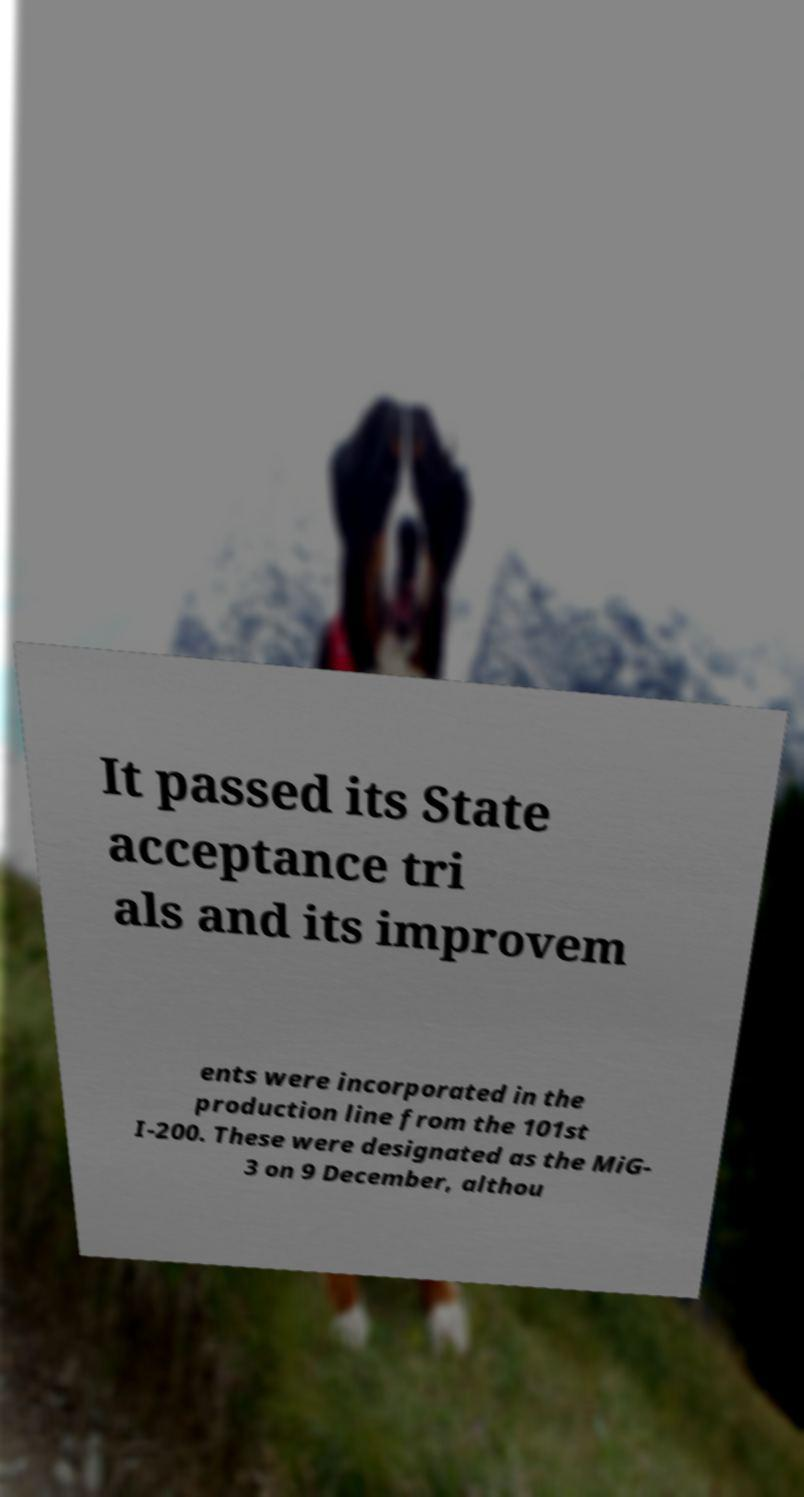I need the written content from this picture converted into text. Can you do that? It passed its State acceptance tri als and its improvem ents were incorporated in the production line from the 101st I-200. These were designated as the MiG- 3 on 9 December, althou 